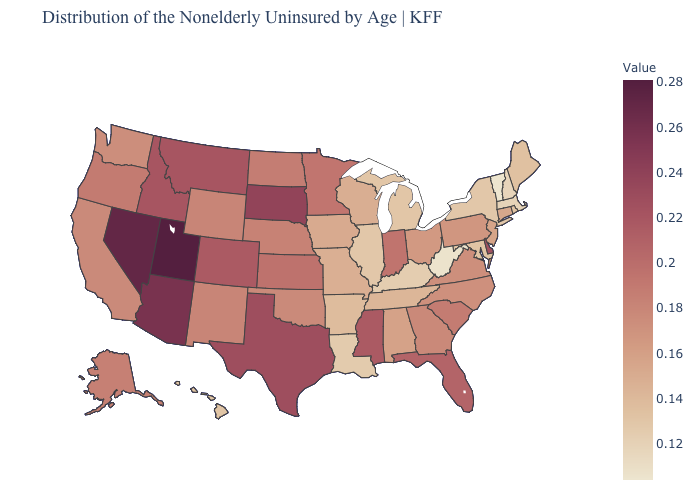Which states have the lowest value in the USA?
Answer briefly. Vermont. Which states hav the highest value in the West?
Quick response, please. Utah. Among the states that border Virginia , does North Carolina have the highest value?
Write a very short answer. Yes. Does Nebraska have a higher value than Montana?
Short answer required. No. Which states have the highest value in the USA?
Short answer required. Utah. 